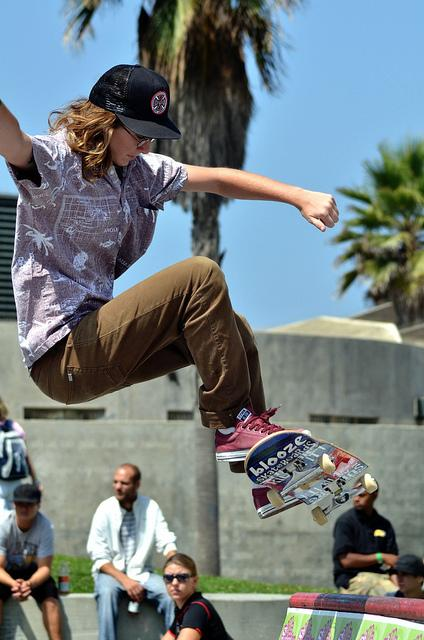In what style park does the skateboarder skate?

Choices:
A) skate park
B) state park
C) store
D) aviary skate park 